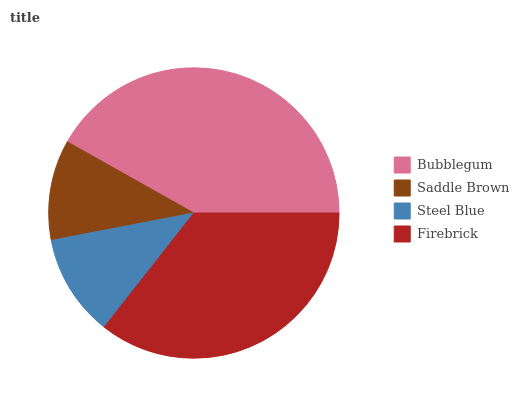Is Saddle Brown the minimum?
Answer yes or no. Yes. Is Bubblegum the maximum?
Answer yes or no. Yes. Is Steel Blue the minimum?
Answer yes or no. No. Is Steel Blue the maximum?
Answer yes or no. No. Is Steel Blue greater than Saddle Brown?
Answer yes or no. Yes. Is Saddle Brown less than Steel Blue?
Answer yes or no. Yes. Is Saddle Brown greater than Steel Blue?
Answer yes or no. No. Is Steel Blue less than Saddle Brown?
Answer yes or no. No. Is Firebrick the high median?
Answer yes or no. Yes. Is Steel Blue the low median?
Answer yes or no. Yes. Is Saddle Brown the high median?
Answer yes or no. No. Is Saddle Brown the low median?
Answer yes or no. No. 